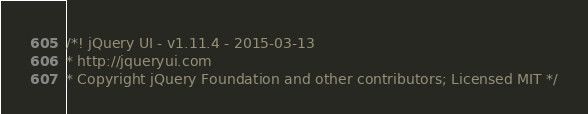<code> <loc_0><loc_0><loc_500><loc_500><_JavaScript_>/*! jQuery UI - v1.11.4 - 2015-03-13
* http://jqueryui.com
* Copyright jQuery Foundation and other contributors; Licensed MIT */</code> 